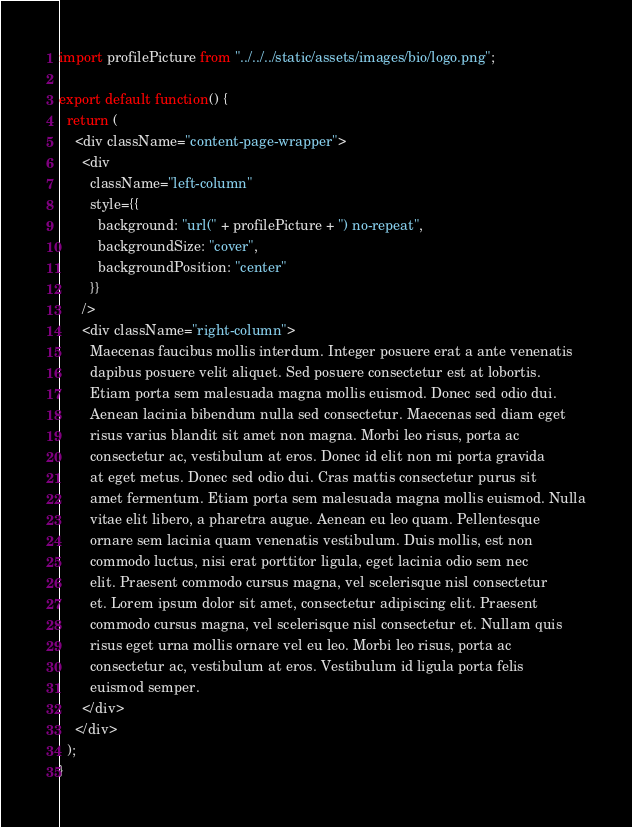<code> <loc_0><loc_0><loc_500><loc_500><_JavaScript_>import profilePicture from "../../../static/assets/images/bio/logo.png";

export default function() {
  return (
    <div className="content-page-wrapper">
      <div
        className="left-column"
        style={{
          background: "url(" + profilePicture + ") no-repeat",
          backgroundSize: "cover",
          backgroundPosition: "center"
        }}
      />
      <div className="right-column">
        Maecenas faucibus mollis interdum. Integer posuere erat a ante venenatis
        dapibus posuere velit aliquet. Sed posuere consectetur est at lobortis.
        Etiam porta sem malesuada magna mollis euismod. Donec sed odio dui.
        Aenean lacinia bibendum nulla sed consectetur. Maecenas sed diam eget
        risus varius blandit sit amet non magna. Morbi leo risus, porta ac
        consectetur ac, vestibulum at eros. Donec id elit non mi porta gravida
        at eget metus. Donec sed odio dui. Cras mattis consectetur purus sit
        amet fermentum. Etiam porta sem malesuada magna mollis euismod. Nulla
        vitae elit libero, a pharetra augue. Aenean eu leo quam. Pellentesque
        ornare sem lacinia quam venenatis vestibulum. Duis mollis, est non
        commodo luctus, nisi erat porttitor ligula, eget lacinia odio sem nec
        elit. Praesent commodo cursus magna, vel scelerisque nisl consectetur
        et. Lorem ipsum dolor sit amet, consectetur adipiscing elit. Praesent
        commodo cursus magna, vel scelerisque nisl consectetur et. Nullam quis
        risus eget urna mollis ornare vel eu leo. Morbi leo risus, porta ac
        consectetur ac, vestibulum at eros. Vestibulum id ligula porta felis
        euismod semper.
      </div>
    </div>
  );
}</code> 